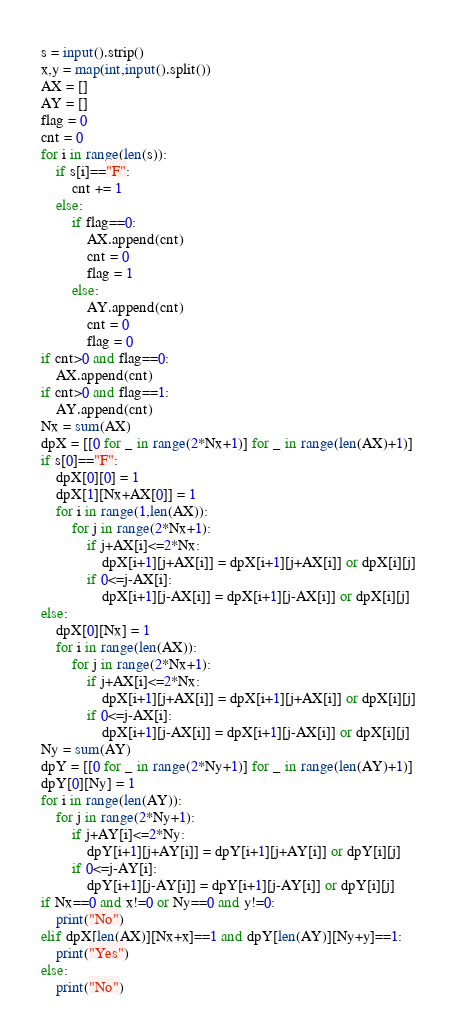Convert code to text. <code><loc_0><loc_0><loc_500><loc_500><_Python_>s = input().strip()
x,y = map(int,input().split())
AX = []
AY = []
flag = 0
cnt = 0
for i in range(len(s)):
    if s[i]=="F":
        cnt += 1
    else:
        if flag==0:
            AX.append(cnt)
            cnt = 0
            flag = 1
        else:
            AY.append(cnt)
            cnt = 0
            flag = 0
if cnt>0 and flag==0:
    AX.append(cnt)
if cnt>0 and flag==1:
    AY.append(cnt)
Nx = sum(AX)
dpX = [[0 for _ in range(2*Nx+1)] for _ in range(len(AX)+1)]
if s[0]=="F":
    dpX[0][0] = 1
    dpX[1][Nx+AX[0]] = 1
    for i in range(1,len(AX)):
        for j in range(2*Nx+1):
            if j+AX[i]<=2*Nx:
                dpX[i+1][j+AX[i]] = dpX[i+1][j+AX[i]] or dpX[i][j]
            if 0<=j-AX[i]:
                dpX[i+1][j-AX[i]] = dpX[i+1][j-AX[i]] or dpX[i][j]
else:
    dpX[0][Nx] = 1
    for i in range(len(AX)):
        for j in range(2*Nx+1):
            if j+AX[i]<=2*Nx:
                dpX[i+1][j+AX[i]] = dpX[i+1][j+AX[i]] or dpX[i][j]
            if 0<=j-AX[i]:
                dpX[i+1][j-AX[i]] = dpX[i+1][j-AX[i]] or dpX[i][j]
Ny = sum(AY)
dpY = [[0 for _ in range(2*Ny+1)] for _ in range(len(AY)+1)]
dpY[0][Ny] = 1
for i in range(len(AY)):
    for j in range(2*Ny+1):
        if j+AY[i]<=2*Ny:
            dpY[i+1][j+AY[i]] = dpY[i+1][j+AY[i]] or dpY[i][j]
        if 0<=j-AY[i]:
            dpY[i+1][j-AY[i]] = dpY[i+1][j-AY[i]] or dpY[i][j]
if Nx==0 and x!=0 or Ny==0 and y!=0:
    print("No")
elif dpX[len(AX)][Nx+x]==1 and dpY[len(AY)][Ny+y]==1:
    print("Yes")
else:
    print("No")</code> 